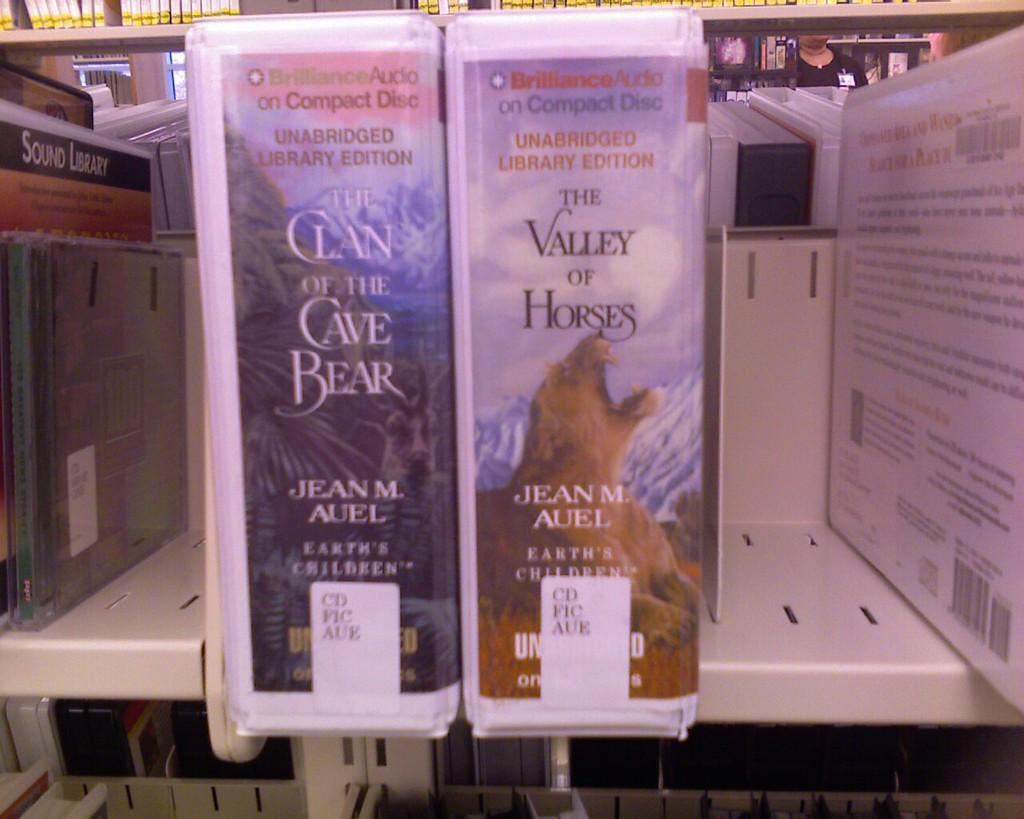<image>
Offer a succinct explanation of the picture presented. Two audio books by Jean M Auel sit on a shelf at the library. 